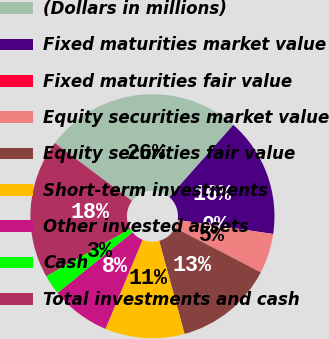Convert chart to OTSL. <chart><loc_0><loc_0><loc_500><loc_500><pie_chart><fcel>(Dollars in millions)<fcel>Fixed maturities market value<fcel>Fixed maturities fair value<fcel>Equity securities market value<fcel>Equity securities fair value<fcel>Short-term investments<fcel>Other invested assets<fcel>Cash<fcel>Total investments and cash<nl><fcel>26.3%<fcel>15.79%<fcel>0.01%<fcel>5.27%<fcel>13.16%<fcel>10.53%<fcel>7.9%<fcel>2.64%<fcel>18.42%<nl></chart> 